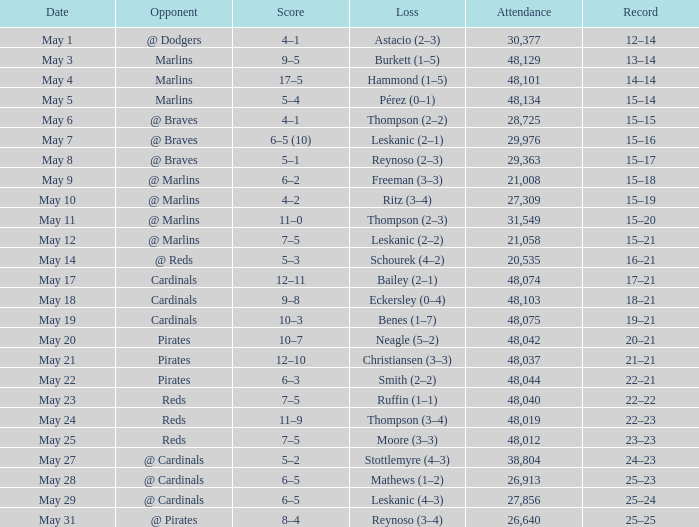Who did the Rockies play at the game that had a score of 6–5 (10)? @ Braves. 